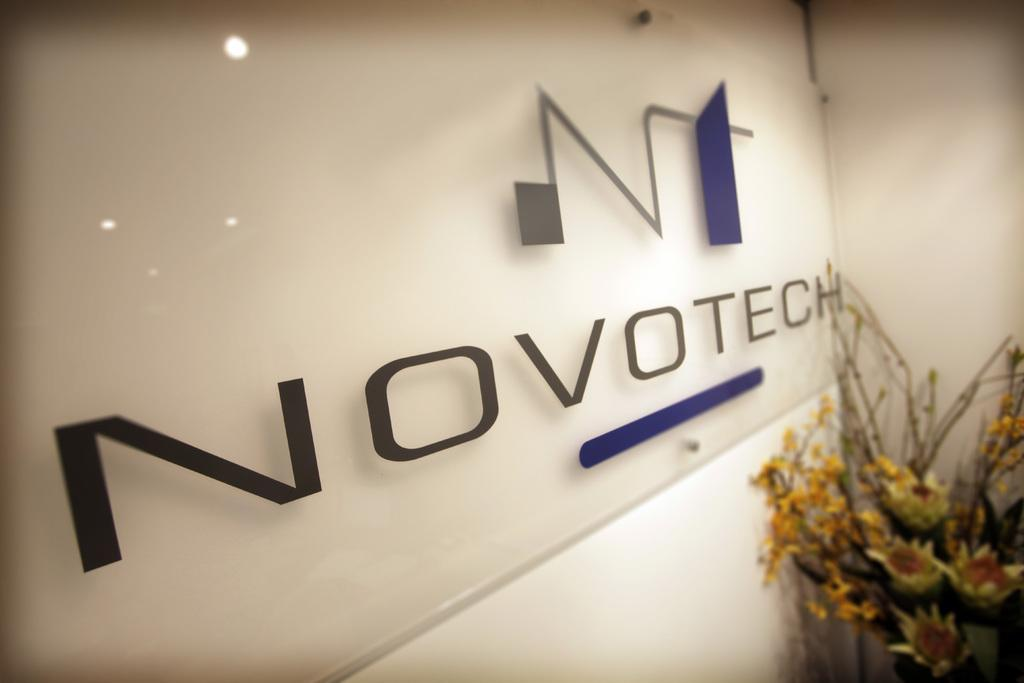What type of surface is visible in the image? There is a glass board in the image. What is the background of the image? There is a wall in the image. Are there any plants in the image? Yes, there is a houseplant in the image. Where was the image taken? The image was taken in a hall. What year was the sheet of paper signed in the image? There is no sheet of paper or any indication of a signing event in the image. 